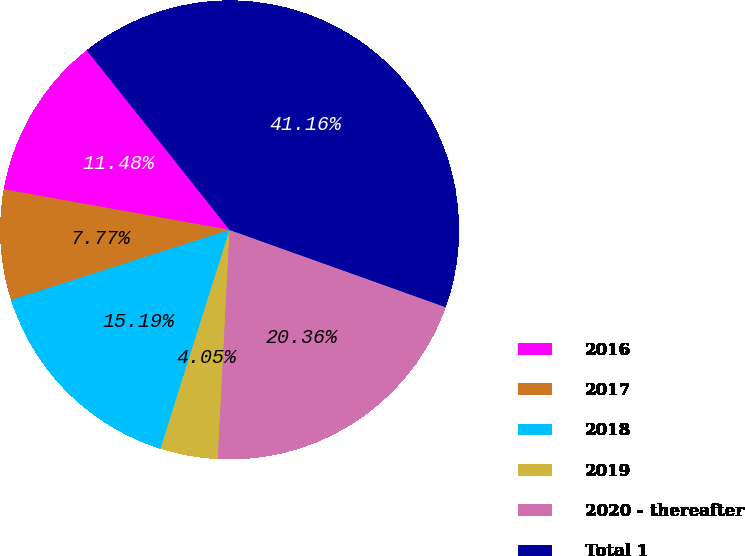<chart> <loc_0><loc_0><loc_500><loc_500><pie_chart><fcel>2016<fcel>2017<fcel>2018<fcel>2019<fcel>2020 - thereafter<fcel>Total 1<nl><fcel>11.48%<fcel>7.77%<fcel>15.19%<fcel>4.05%<fcel>20.36%<fcel>41.16%<nl></chart> 